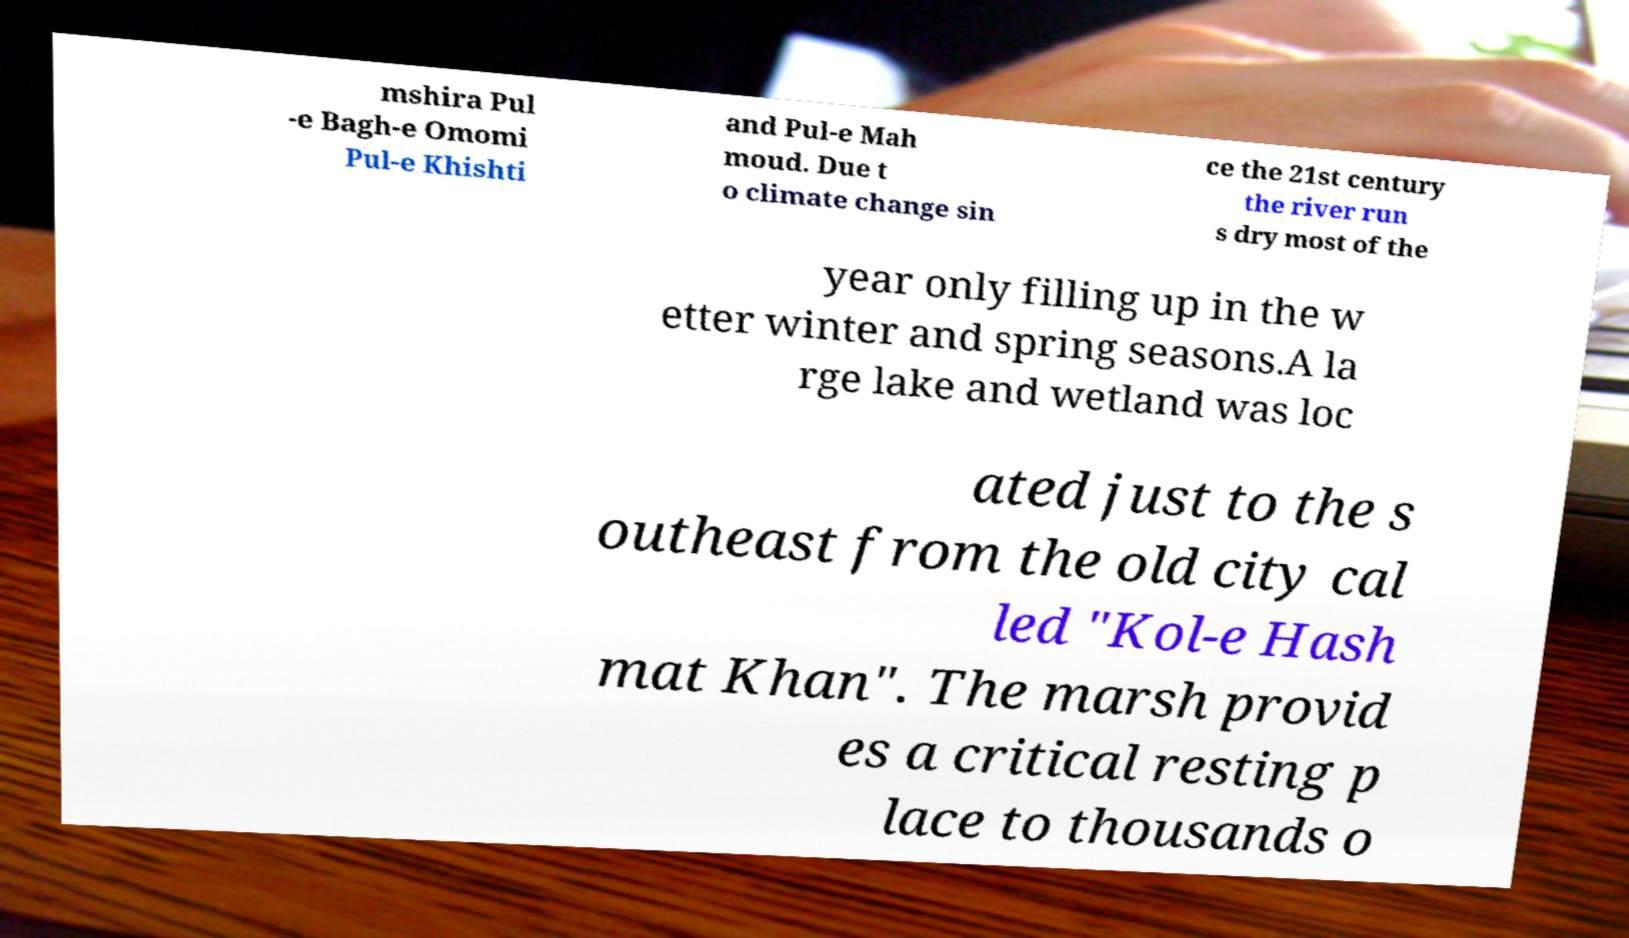Please read and relay the text visible in this image. What does it say? mshira Pul -e Bagh-e Omomi Pul-e Khishti and Pul-e Mah moud. Due t o climate change sin ce the 21st century the river run s dry most of the year only filling up in the w etter winter and spring seasons.A la rge lake and wetland was loc ated just to the s outheast from the old city cal led "Kol-e Hash mat Khan". The marsh provid es a critical resting p lace to thousands o 